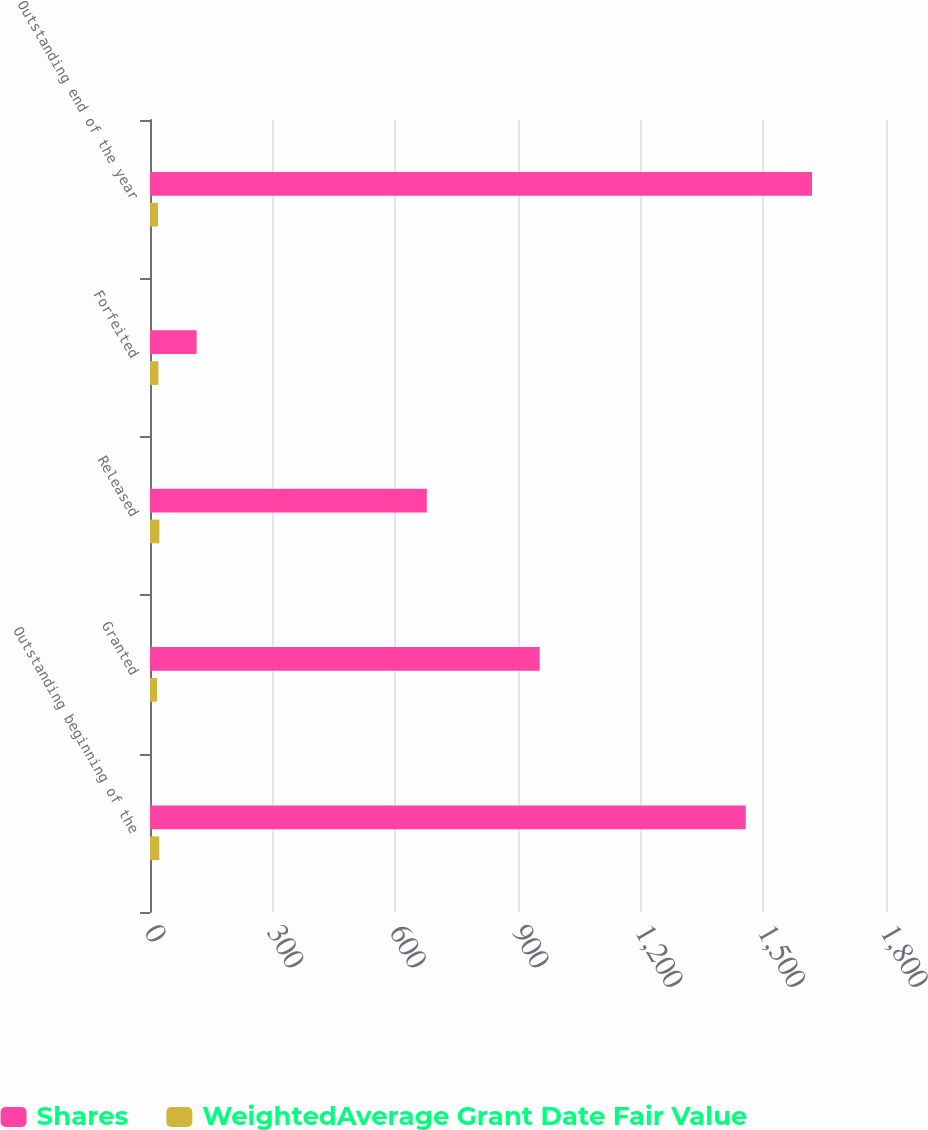Convert chart to OTSL. <chart><loc_0><loc_0><loc_500><loc_500><stacked_bar_chart><ecel><fcel>Outstanding beginning of the<fcel>Granted<fcel>Released<fcel>Forfeited<fcel>Outstanding end of the year<nl><fcel>Shares<fcel>1457<fcel>953<fcel>677<fcel>114<fcel>1619<nl><fcel>WeightedAverage Grant Date Fair Value<fcel>22.73<fcel>17.04<fcel>22.94<fcel>20.52<fcel>19.55<nl></chart> 